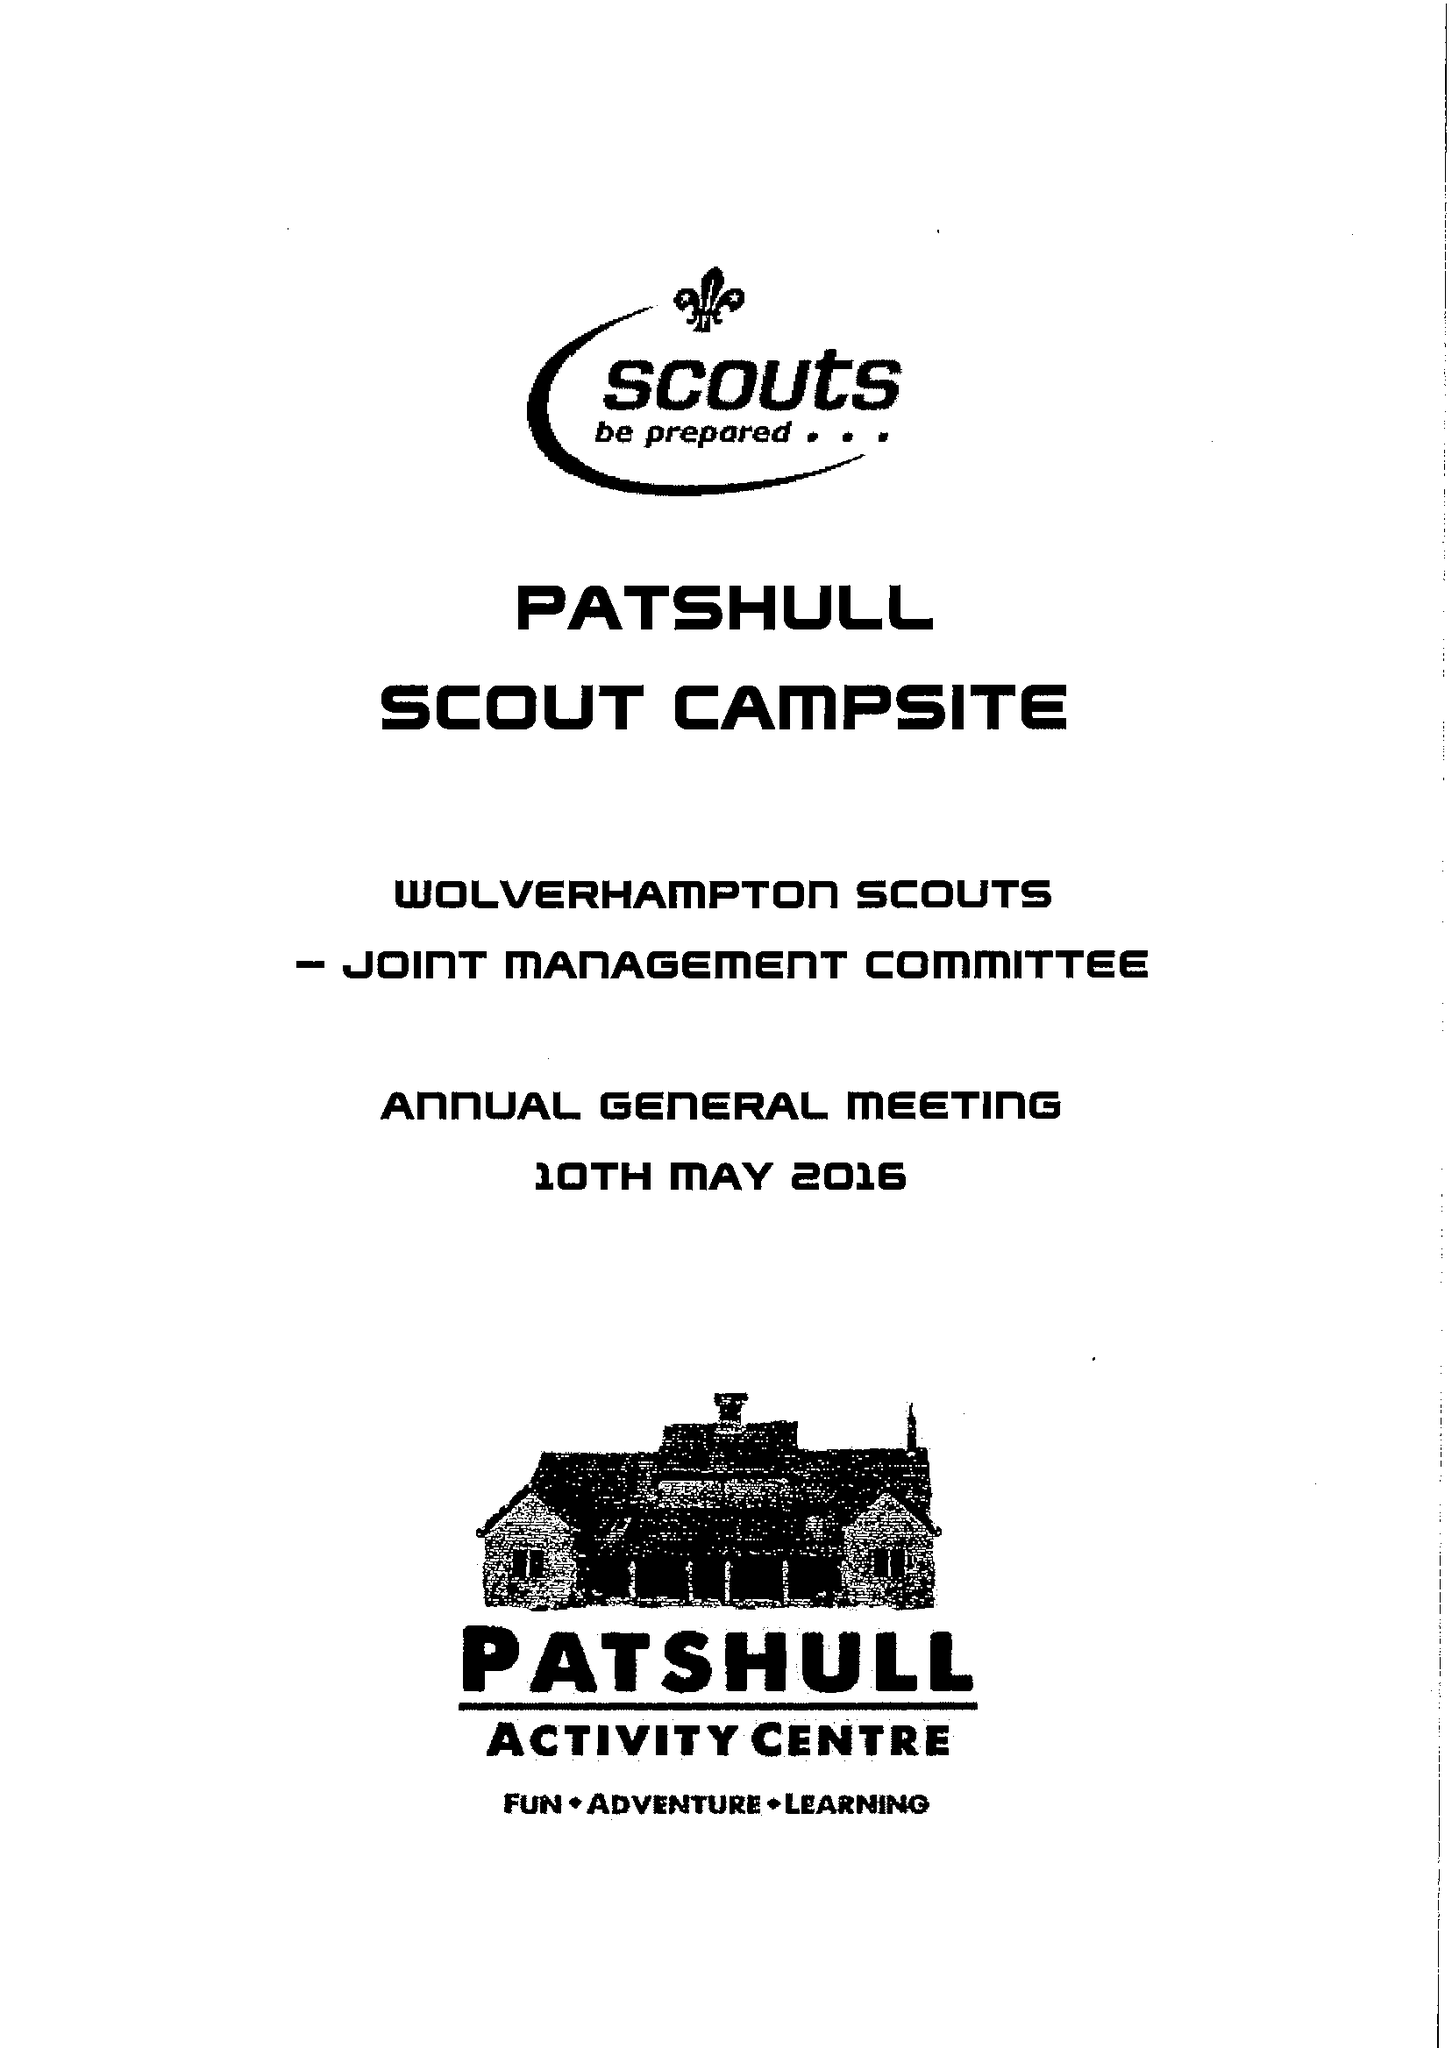What is the value for the report_date?
Answer the question using a single word or phrase. 2016-03-31 